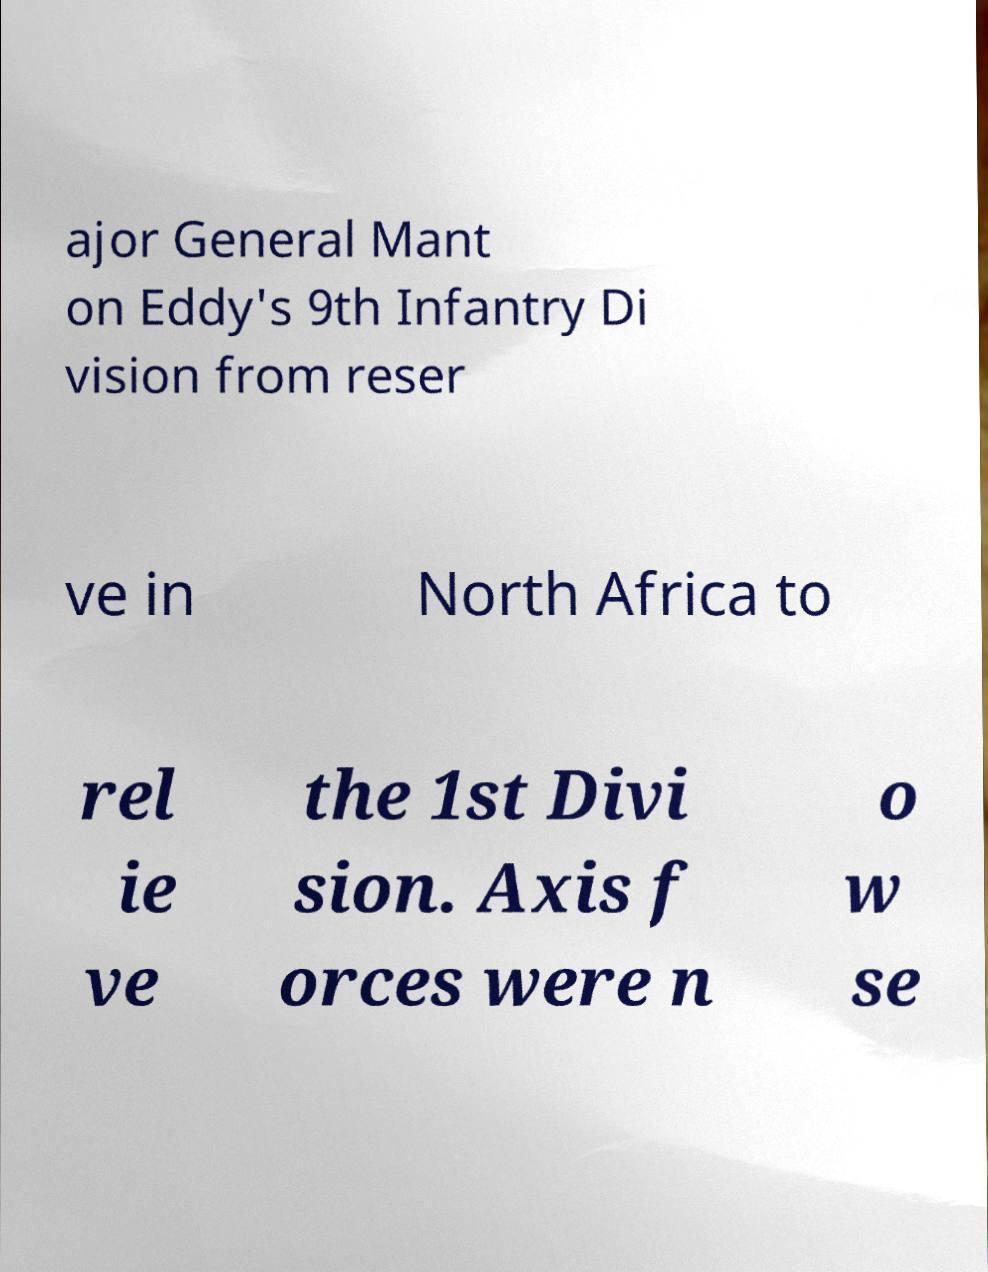I need the written content from this picture converted into text. Can you do that? ajor General Mant on Eddy's 9th Infantry Di vision from reser ve in North Africa to rel ie ve the 1st Divi sion. Axis f orces were n o w se 